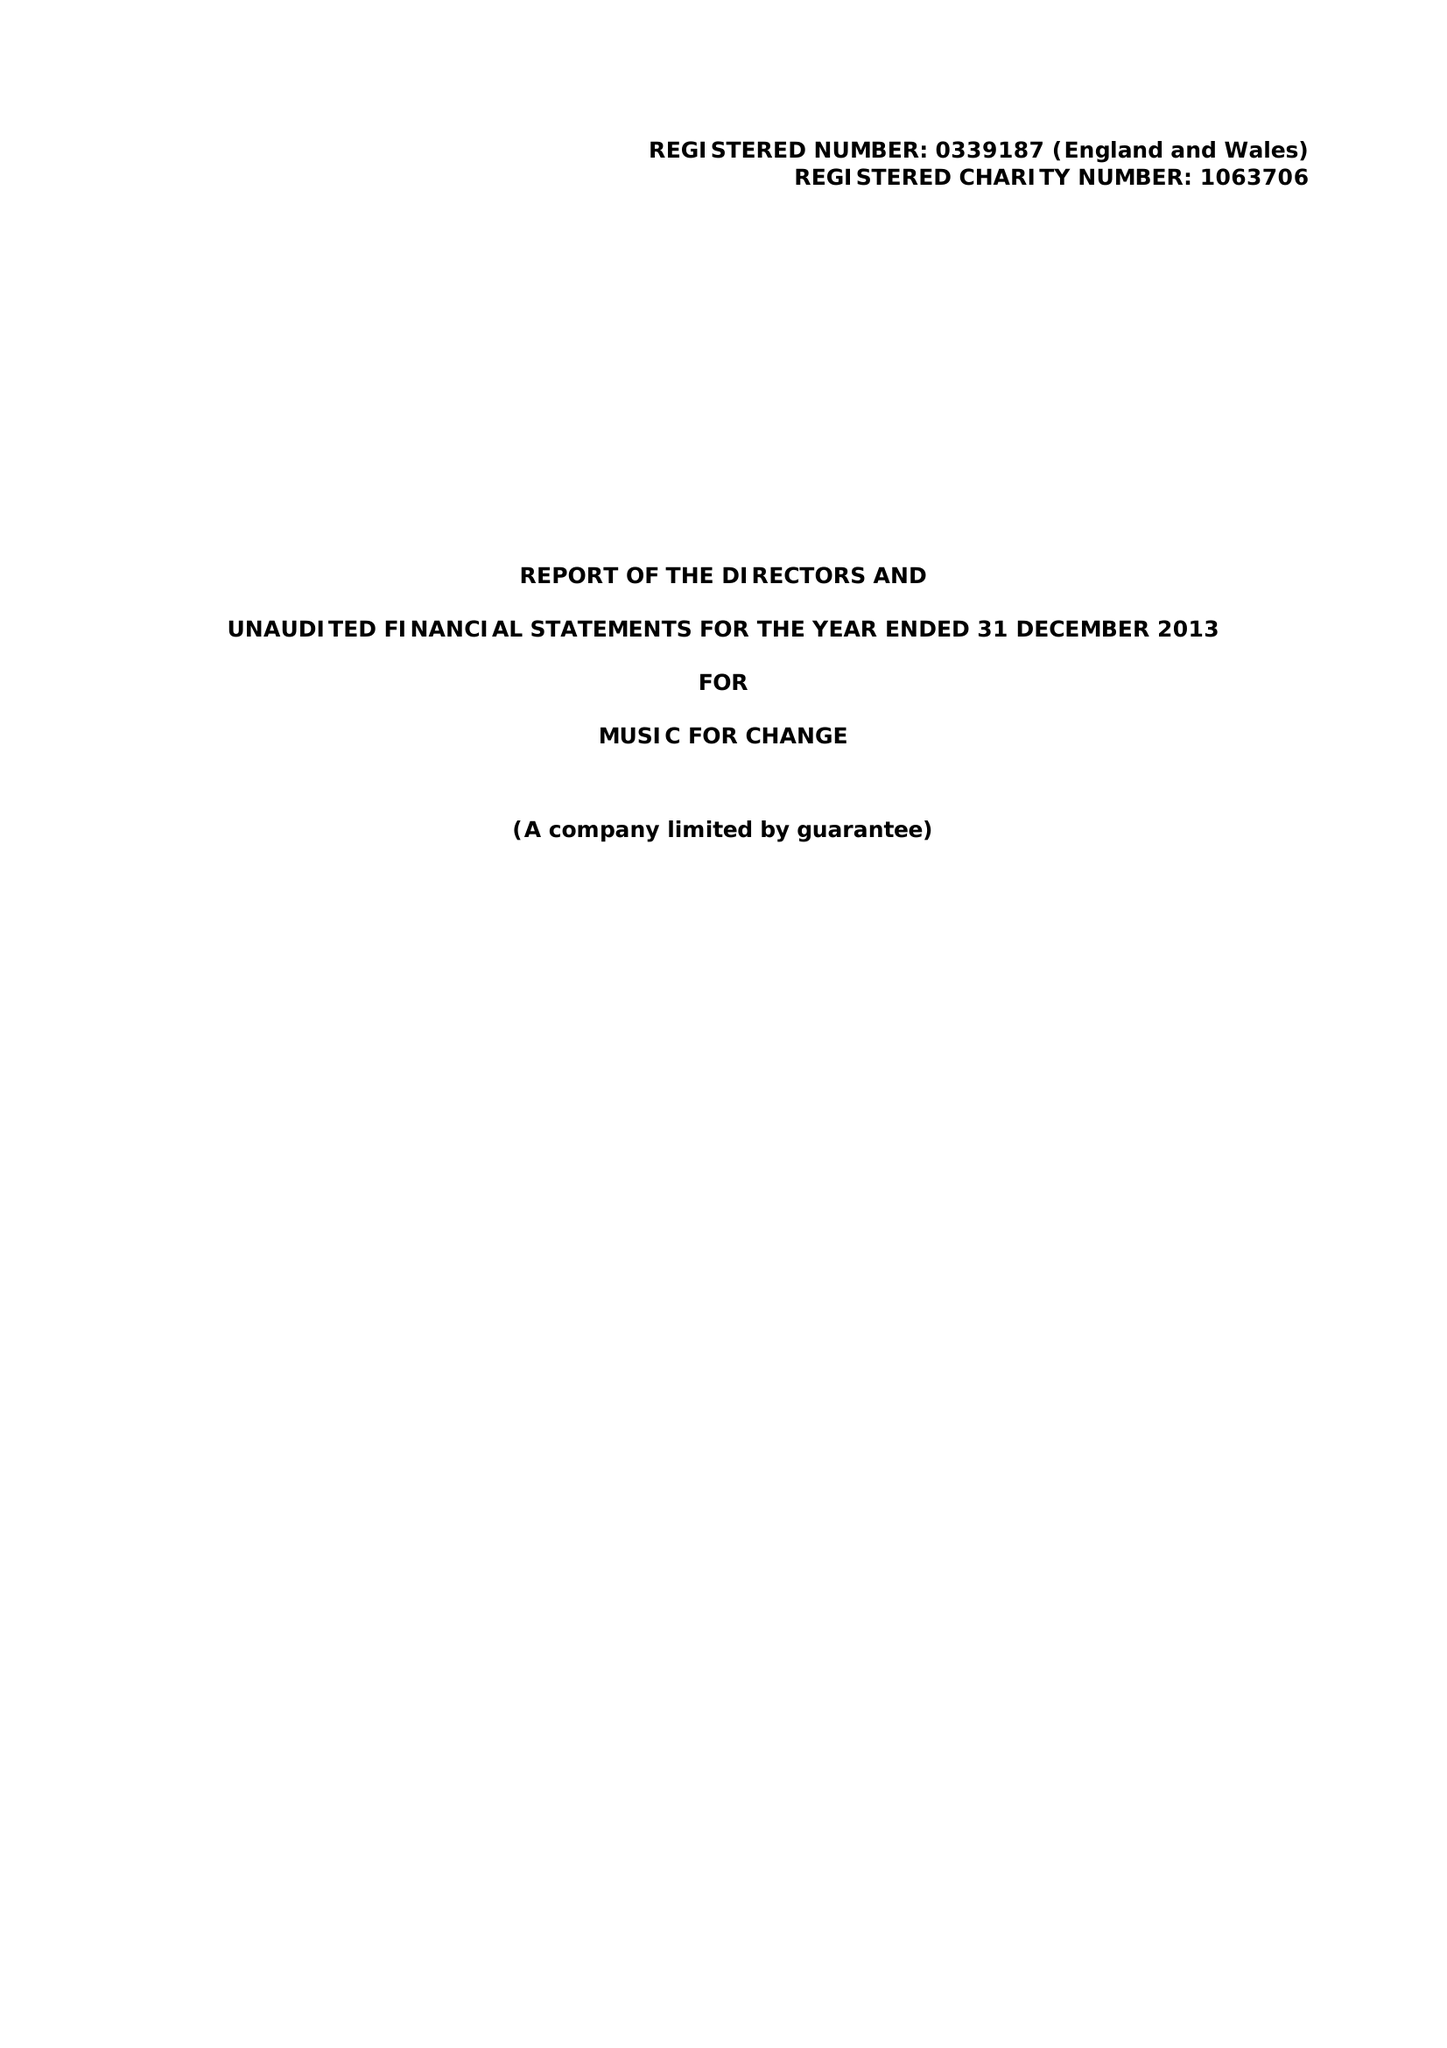What is the value for the report_date?
Answer the question using a single word or phrase. 2013-12-31 